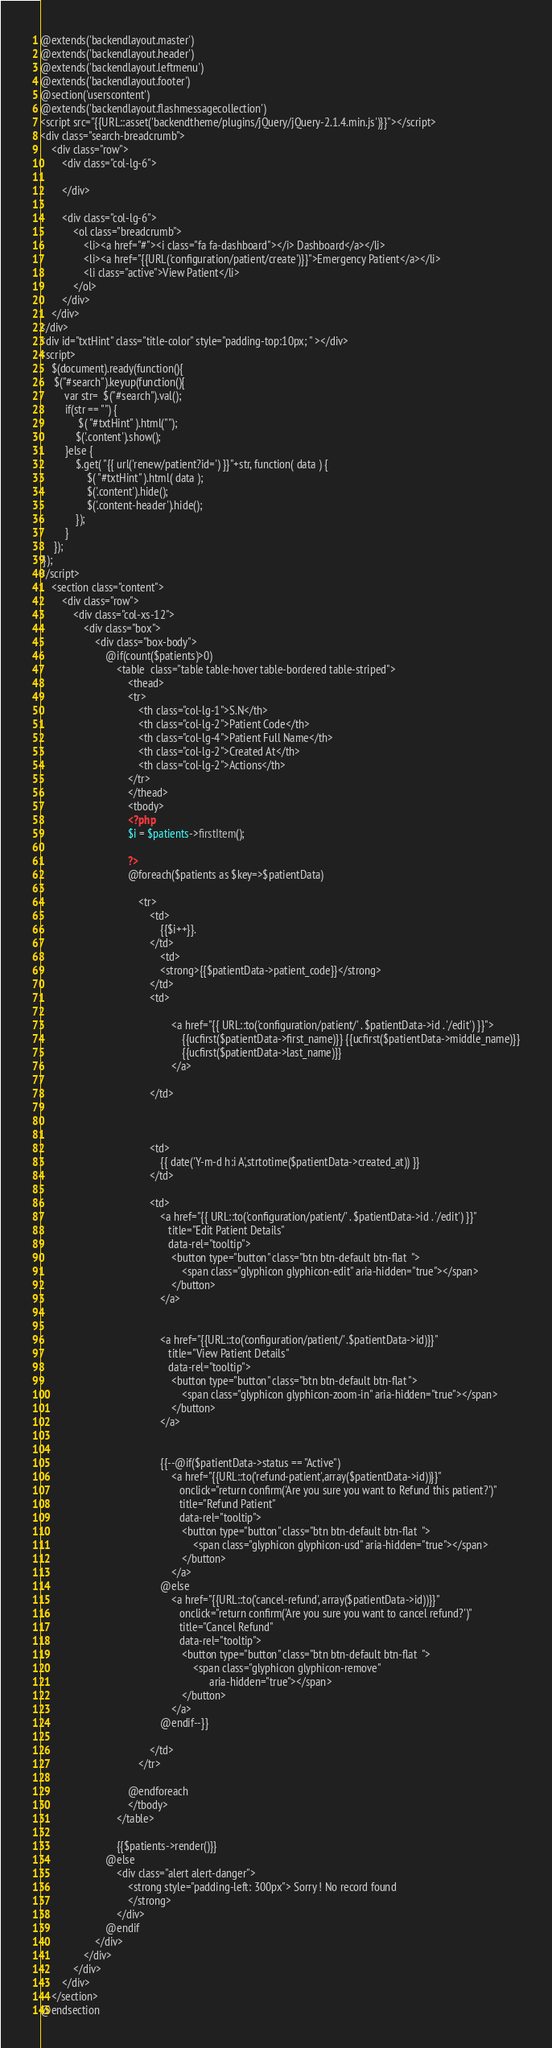<code> <loc_0><loc_0><loc_500><loc_500><_PHP_>@extends('backendlayout.master')
@extends('backendlayout.header')
@extends('backendlayout.leftmenu')
@extends('backendlayout.footer')
@section('userscontent')
@extends('backendlayout.flashmessagecollection')
<script src="{{URL::asset('backendtheme/plugins/jQuery/jQuery-2.1.4.min.js')}}"></script>
<div class="search-breadcrumb">
    <div class="row">
        <div class="col-lg-6">
           
        </div>

        <div class="col-lg-6">
            <ol class="breadcrumb">
                <li><a href="#"><i class="fa fa-dashboard"></i> Dashboard</a></li>
                <li><a href="{{URL('configuration/patient/create')}}">Emergency Patient</a></li>
                <li class="active">View Patient</li>
            </ol>
        </div>
    </div>   
</div>  
<div id="txtHint" class="title-color" style="padding-top:10px; " ></div>  
<script>
    $(document).ready(function(){
     $("#search").keyup(function(){
         var str=  $("#search").val();
         if(str == "") {
              $( "#txtHint" ).html("");
             $('.content').show(); 
         }else {
             $.get( "{{ url('renew/patient?id=') }}"+str, function( data ) {
                 $( "#txtHint" ).html( data );
                 $('.content').hide();
                 $('.content-header').hide();
             });
         }
     });  
 }); 
</script>
    <section class="content">
        <div class="row">
            <div class="col-xs-12">
                <div class="box">
                    <div class="box-body">
                        @if(count($patients)>0)
                            <table  class="table table-hover table-bordered table-striped">
                                <thead>
                                <tr>
                                    <th class="col-lg-1">S.N</th>
                                    <th class="col-lg-2">Patient Code</th>
                                    <th class="col-lg-4">Patient Full Name</th>
                                    <th class="col-lg-2">Created At</th>
                                    <th class="col-lg-2">Actions</th>
                                </tr>
                                </thead>
                                <tbody>
                                <?php
                                $i = $patients->firstItem();

                                ?>
                                @foreach($patients as $key=>$patientData)

                                    <tr>
                                        <td>
                                            {{$i++}}.
                                        </td>
                                            <td>
                                            <strong>{{$patientData->patient_code}}</strong>
                                        </td>
                                        <td>
                                            
                                                <a href="{{ URL::to('configuration/patient/' . $patientData->id . '/edit') }}">
                                                    {{ucfirst($patientData->first_name)}} {{ucfirst($patientData->middle_name)}}
                                                    {{ucfirst($patientData->last_name)}}
                                                </a>
                                           
                                        </td>

                                        

                                        <td>
                                            {{ date('Y-m-d h:i A',strtotime($patientData->created_at)) }}
                                        </td>

                                        <td>
                                            <a href="{{ URL::to('configuration/patient/' . $patientData->id . '/edit') }}"
                                               title="Edit Patient Details"
                                               data-rel="tooltip">
                                                <button type="button" class="btn btn-default btn-flat  ">
                                                    <span class="glyphicon glyphicon-edit" aria-hidden="true"></span>
                                                </button>
                                            </a>


                                            <a href="{{URL::to('configuration/patient/' .$patientData->id)}}"
                                               title="View Patient Details"
                                               data-rel="tooltip">
                                                <button type="button" class="btn btn-default btn-flat ">
                                                    <span class="glyphicon glyphicon-zoom-in" aria-hidden="true"></span>
                                                </button>
                                            </a>


                                            {{--@if($patientData->status == "Active")
                                                <a href="{{URL::to('refund-patient',array($patientData->id))}}"
                                                   onclick="return confirm('Are you sure you want to Refund this patient?')"
                                                   title="Refund Patient"
                                                   data-rel="tooltip">
                                                    <button type="button" class="btn btn-default btn-flat  ">
                                                        <span class="glyphicon glyphicon-usd" aria-hidden="true"></span>
                                                    </button>
                                                </a>
                                            @else
                                                <a href="{{URL::to('cancel-refund', array($patientData->id))}}"
                                                   onclick="return confirm('Are you sure you want to cancel refund?')"
                                                   title="Cancel Refund"
                                                   data-rel="tooltip">
                                                    <button type="button" class="btn btn-default btn-flat  ">
                                                        <span class="glyphicon glyphicon-remove"
                                                              aria-hidden="true"></span>
                                                    </button>
                                                </a>
                                            @endif--}}

                                        </td>
                                    </tr>

                                @endforeach
                                </tbody>
                            </table>

                            {{$patients->render()}}
                        @else
                            <div class="alert alert-danger">
                                <strong style="padding-left: 300px"> Sorry ! No record found
                                </strong>
                            </div>
                        @endif
                    </div>
                </div>
            </div>
        </div>
    </section>
@endsection</code> 